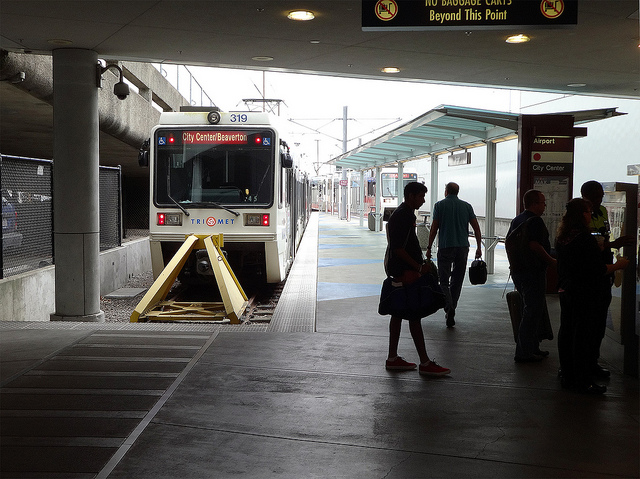Identify the text contained in this image. Airport 319 TRI MET Point City NO Beaverton This Beyond 